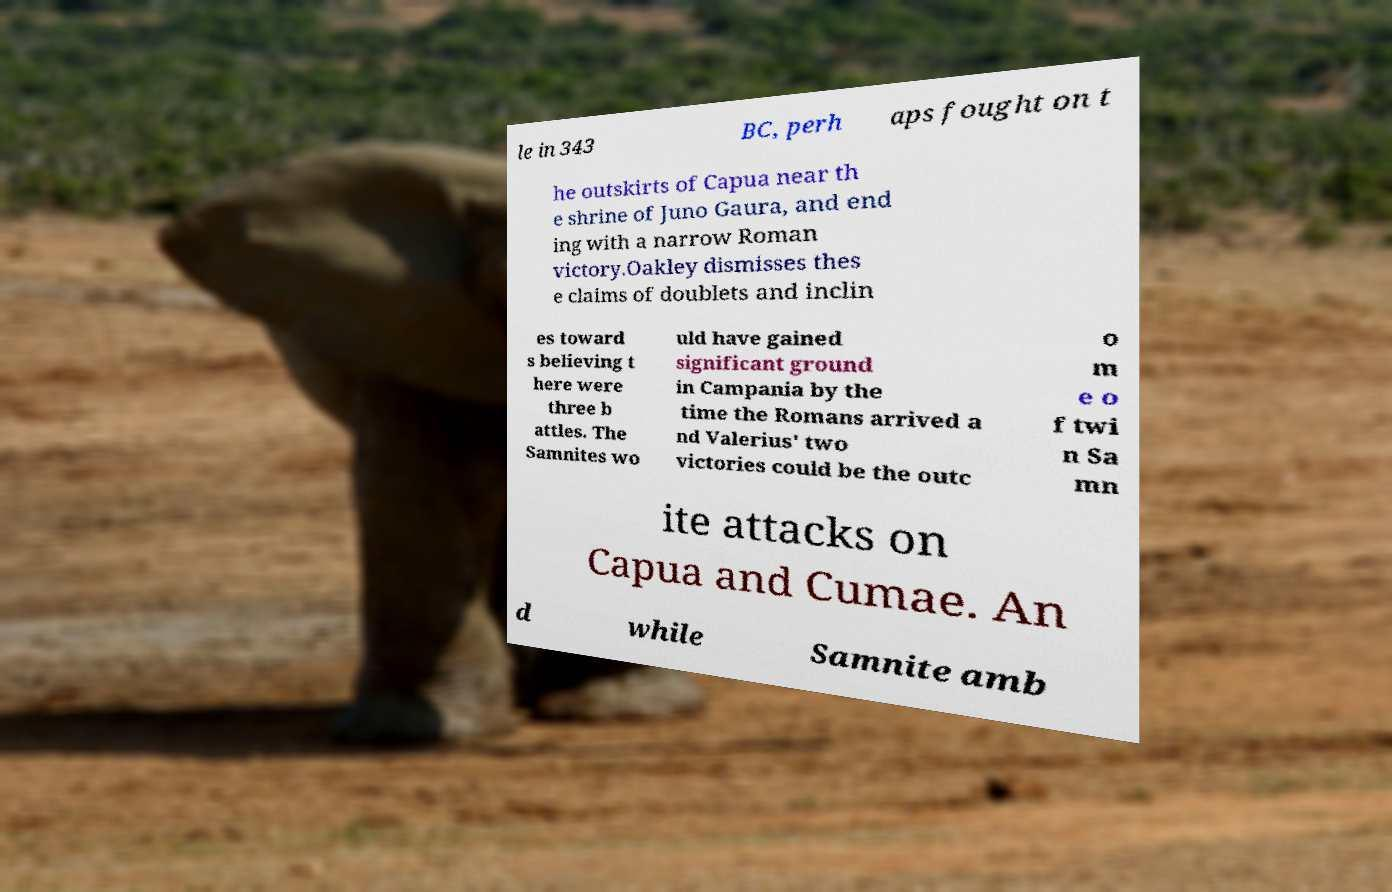Can you accurately transcribe the text from the provided image for me? le in 343 BC, perh aps fought on t he outskirts of Capua near th e shrine of Juno Gaura, and end ing with a narrow Roman victory.Oakley dismisses thes e claims of doublets and inclin es toward s believing t here were three b attles. The Samnites wo uld have gained significant ground in Campania by the time the Romans arrived a nd Valerius' two victories could be the outc o m e o f twi n Sa mn ite attacks on Capua and Cumae. An d while Samnite amb 